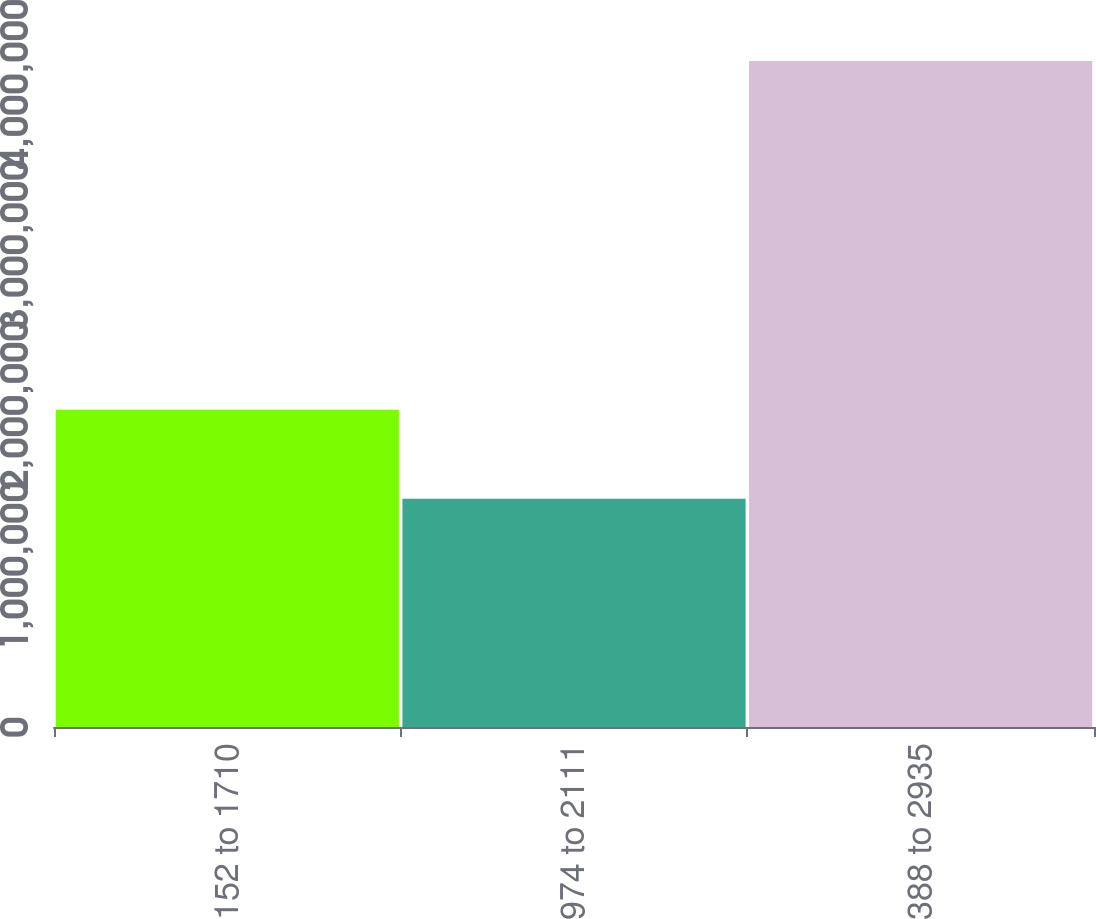Convert chart. <chart><loc_0><loc_0><loc_500><loc_500><bar_chart><fcel>1152 to 1710<fcel>1974 to 2111<fcel>2388 to 2935<nl><fcel>1.97259e+06<fcel>1.42019e+06<fcel>4.1422e+06<nl></chart> 